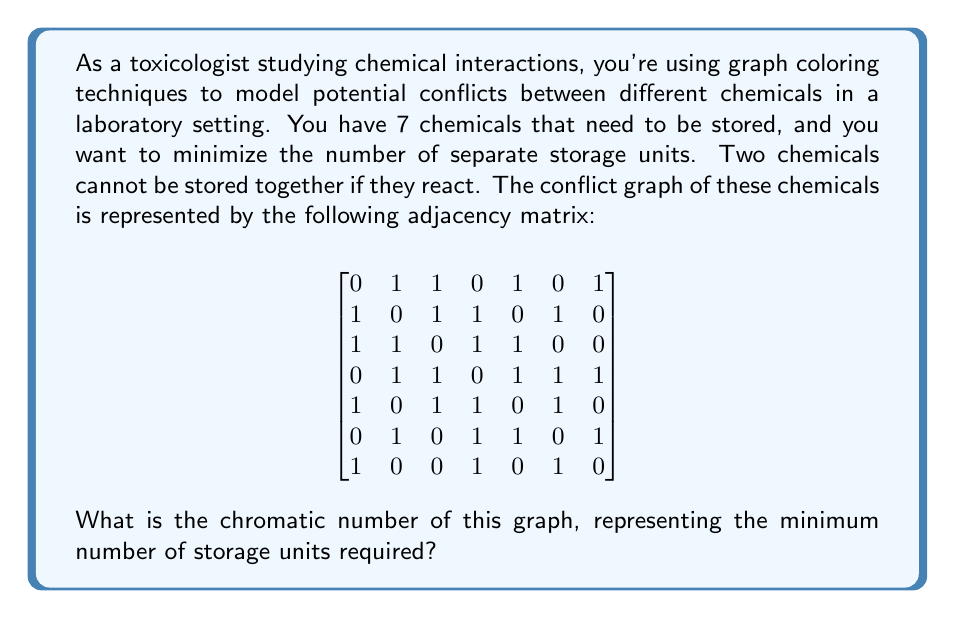Give your solution to this math problem. To solve this problem, we need to find the chromatic number of the given graph. The chromatic number is the minimum number of colors needed to color the vertices of a graph such that no two adjacent vertices have the same color. In this context, each color represents a separate storage unit.

Let's approach this step-by-step:

1) First, we need to understand what the adjacency matrix represents. A 1 in position $(i,j)$ means that chemicals $i$ and $j$ react and cannot be stored together.

2) We can use a greedy coloring algorithm to find an upper bound for the chromatic number:

   a) Start with the first chemical and assign it color 1.
   b) For each subsequent chemical, assign it the lowest-numbered color that hasn't been used by any of its neighbors.

3) Let's apply this algorithm:
   - Chemical 1: Color 1
   - Chemical 2: Color 2 (conflicts with 1)
   - Chemical 3: Color 3 (conflicts with 1 and 2)
   - Chemical 4: Color 1 (no conflict with 1)
   - Chemical 5: Color 2 (conflicts with 1, 3, 4)
   - Chemical 6: Color 1 (conflicts with 2, 4, 5)
   - Chemical 7: Color 3 (conflicts with 1, 4, 6)

4) This greedy algorithm gives us a 3-coloring, so we know the chromatic number is at most 3.

5) To prove that it's exactly 3, we need to show that it can't be 2. We can do this by finding a triangle (clique of size 3) in the graph.

6) Looking at the adjacency matrix, we can see that chemicals 1, 2, and 3 form a triangle (they all conflict with each other). This means we need at least 3 colors.

Therefore, the chromatic number of this graph is exactly 3.
Answer: The chromatic number of the graph is 3, meaning a minimum of 3 storage units are required. 